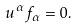Convert formula to latex. <formula><loc_0><loc_0><loc_500><loc_500>u ^ { \alpha } f _ { \alpha } = 0 .</formula> 